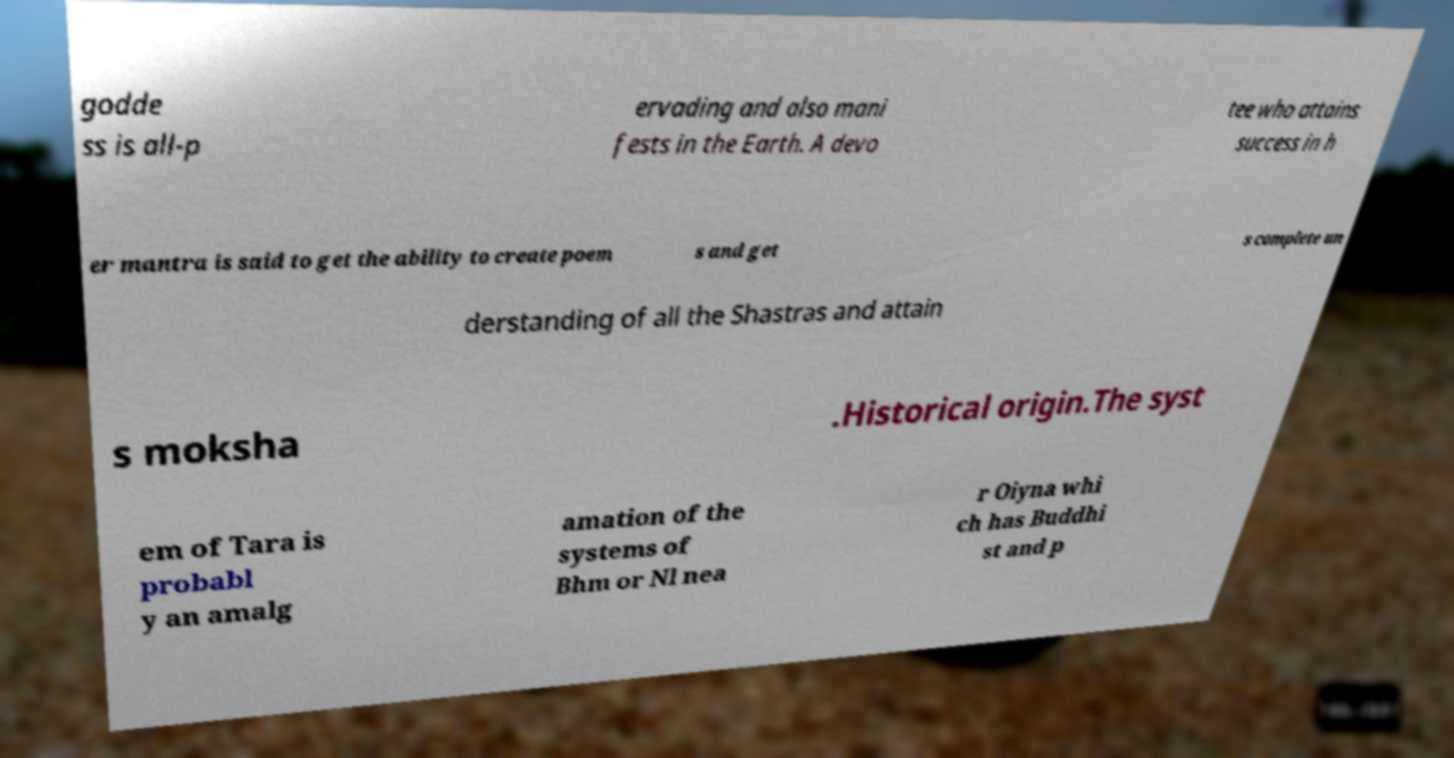Please read and relay the text visible in this image. What does it say? godde ss is all-p ervading and also mani fests in the Earth. A devo tee who attains success in h er mantra is said to get the ability to create poem s and get s complete un derstanding of all the Shastras and attain s moksha .Historical origin.The syst em of Tara is probabl y an amalg amation of the systems of Bhm or Nl nea r Oiyna whi ch has Buddhi st and p 